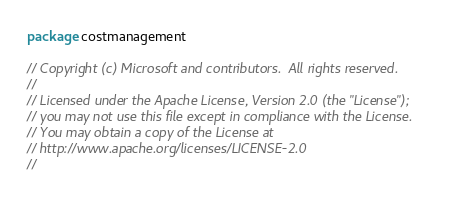Convert code to text. <code><loc_0><loc_0><loc_500><loc_500><_Go_>package costmanagement

// Copyright (c) Microsoft and contributors.  All rights reserved.
//
// Licensed under the Apache License, Version 2.0 (the "License");
// you may not use this file except in compliance with the License.
// You may obtain a copy of the License at
// http://www.apache.org/licenses/LICENSE-2.0
//</code> 